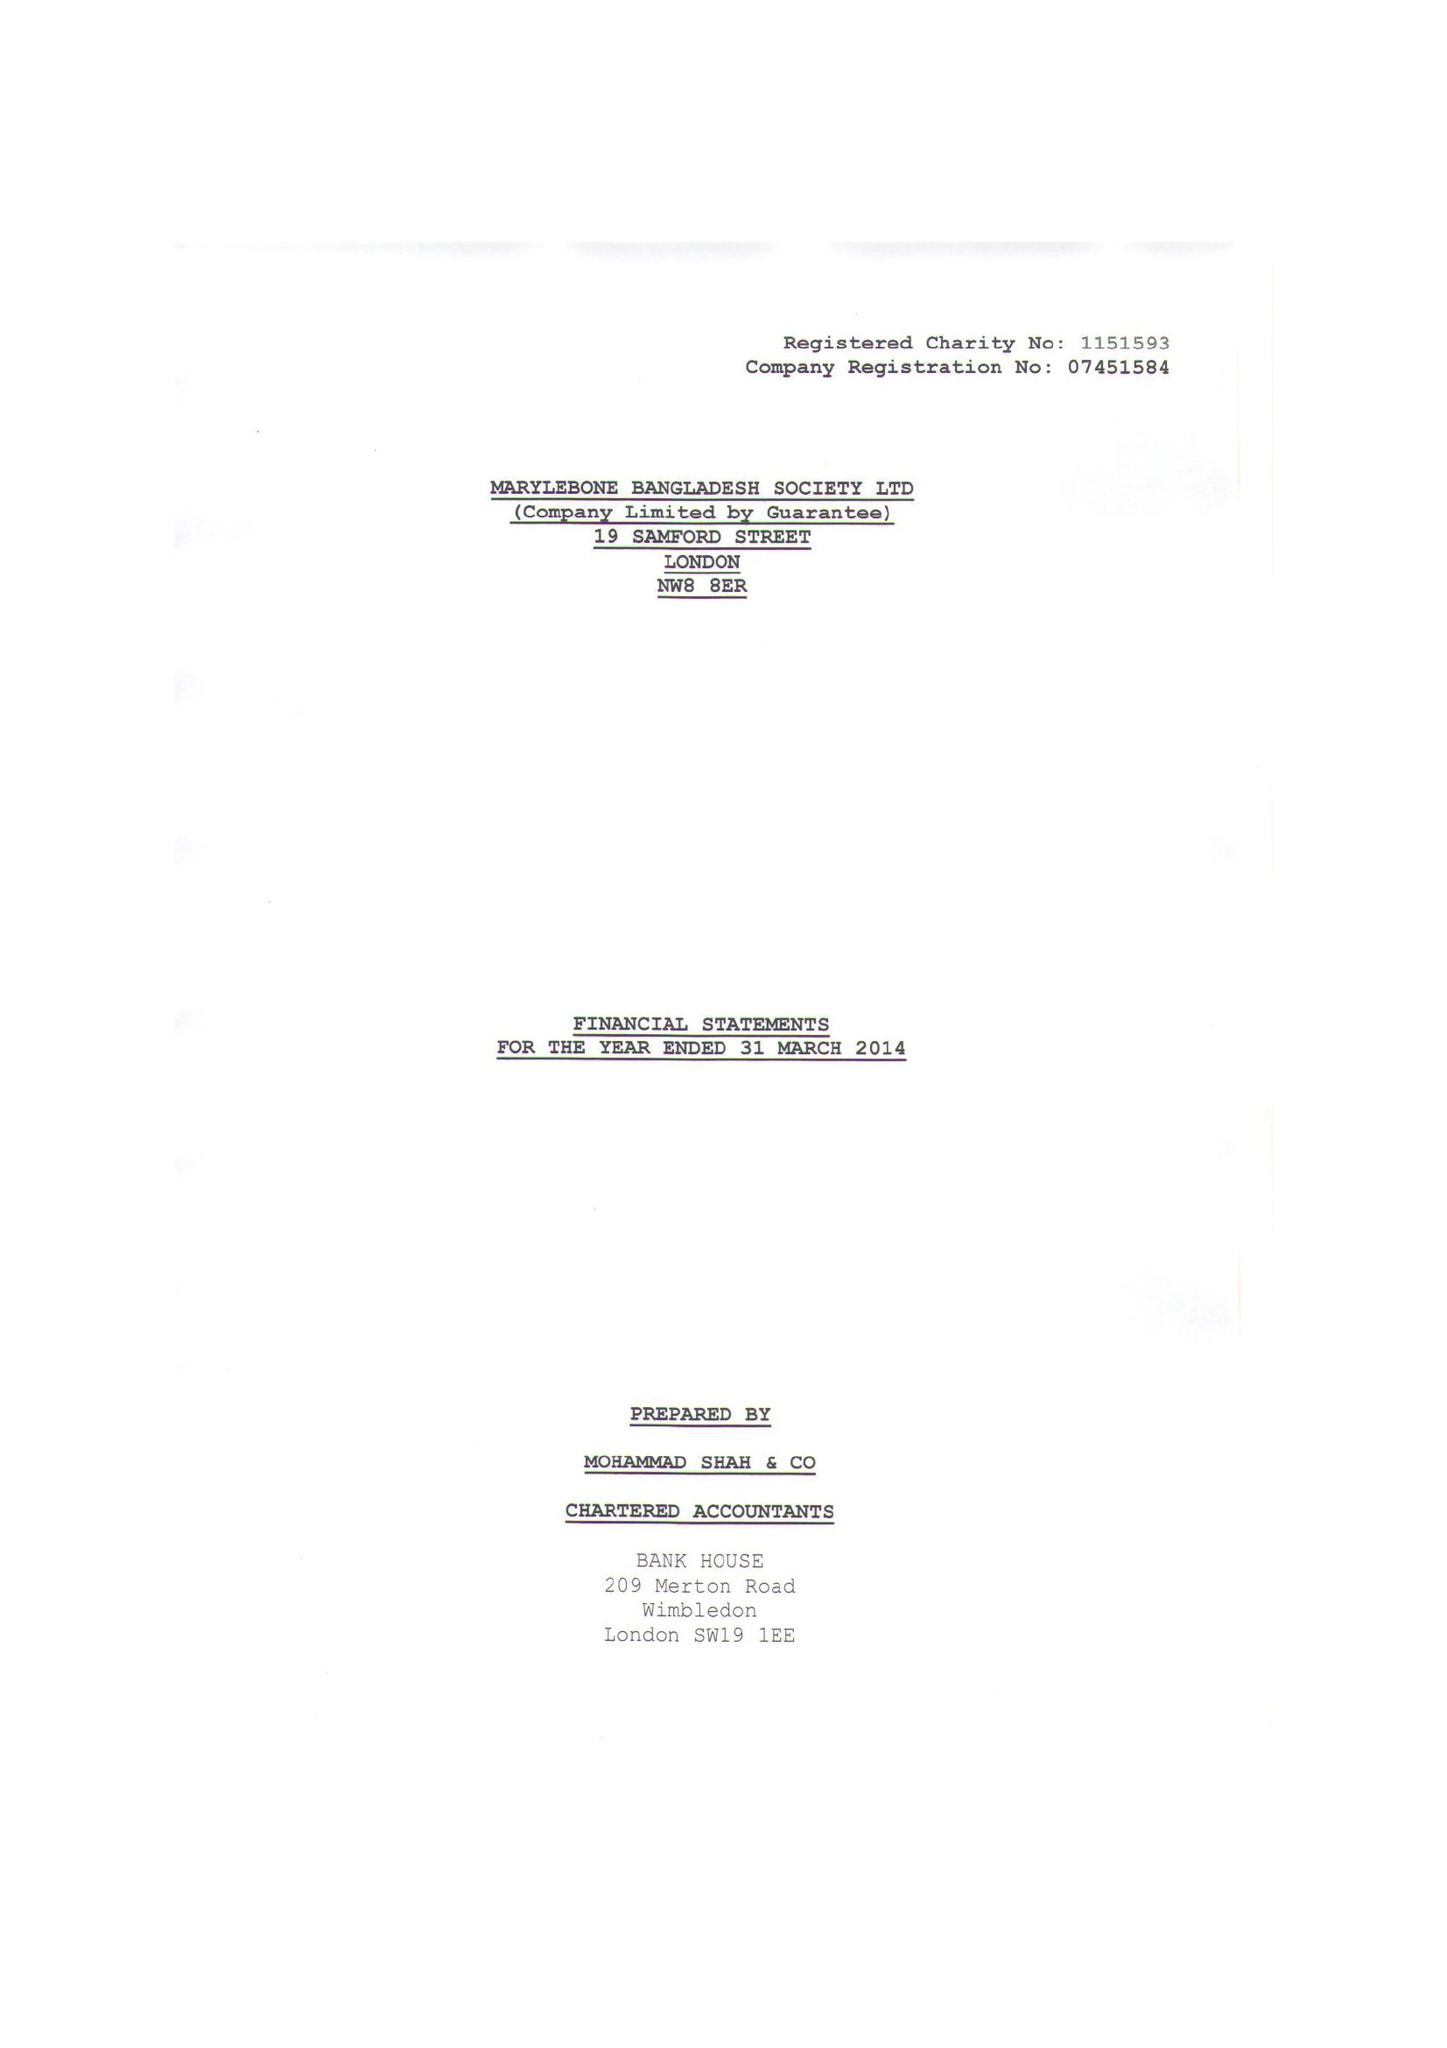What is the value for the report_date?
Answer the question using a single word or phrase. 2014-03-31 